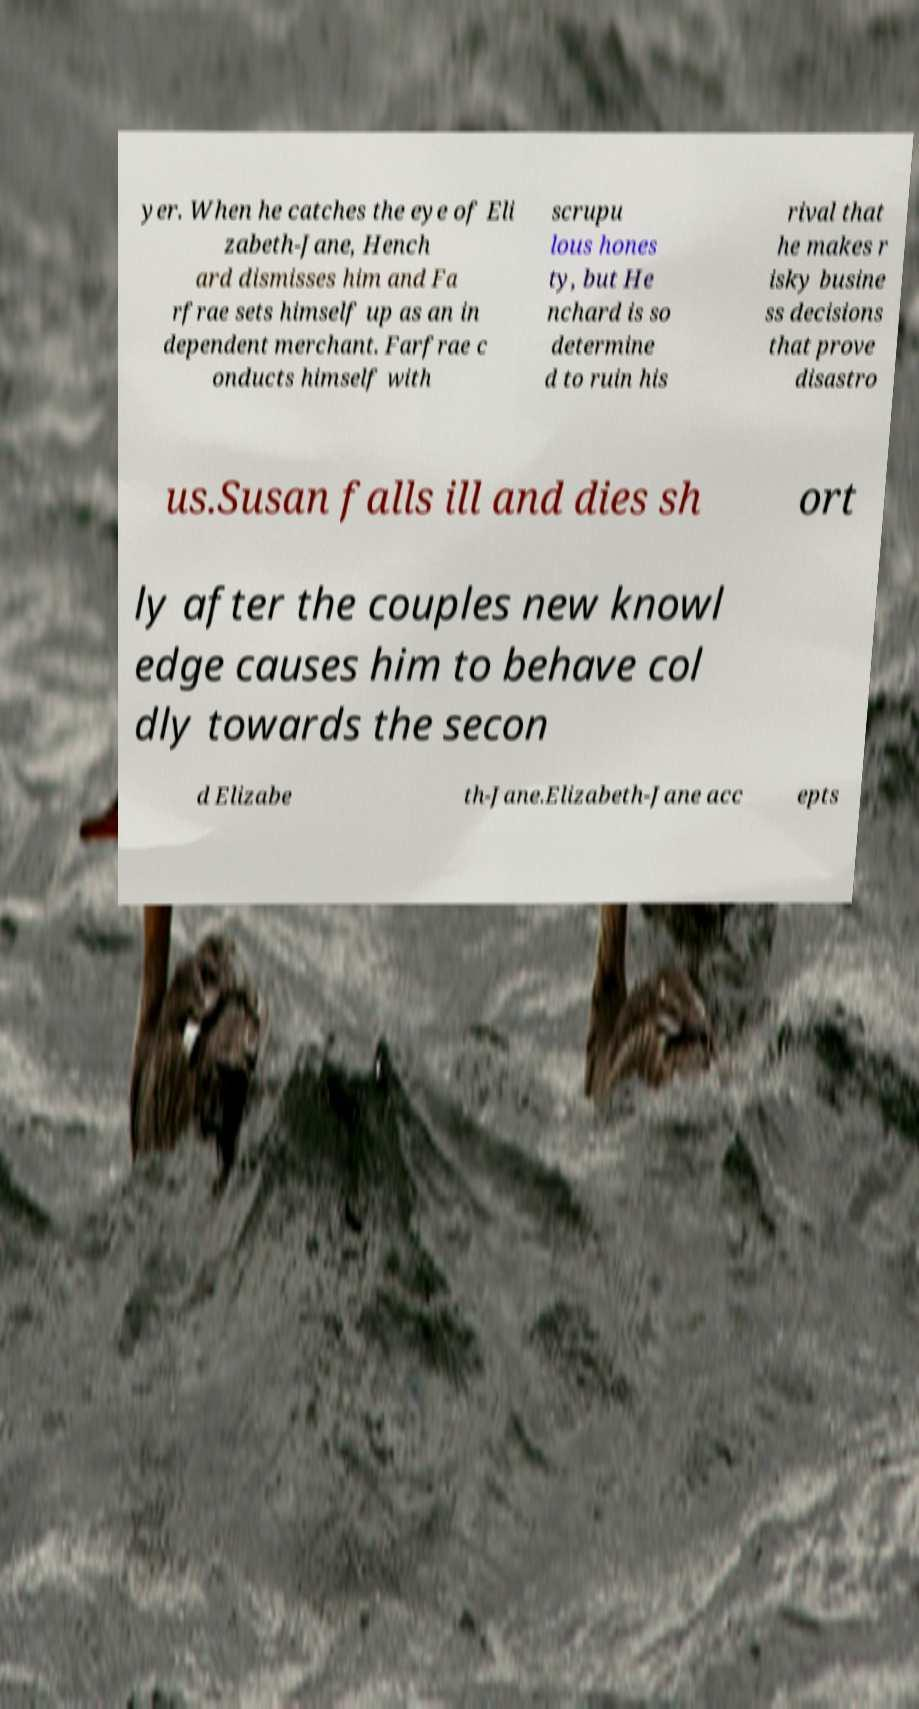Can you read and provide the text displayed in the image?This photo seems to have some interesting text. Can you extract and type it out for me? yer. When he catches the eye of Eli zabeth-Jane, Hench ard dismisses him and Fa rfrae sets himself up as an in dependent merchant. Farfrae c onducts himself with scrupu lous hones ty, but He nchard is so determine d to ruin his rival that he makes r isky busine ss decisions that prove disastro us.Susan falls ill and dies sh ort ly after the couples new knowl edge causes him to behave col dly towards the secon d Elizabe th-Jane.Elizabeth-Jane acc epts 